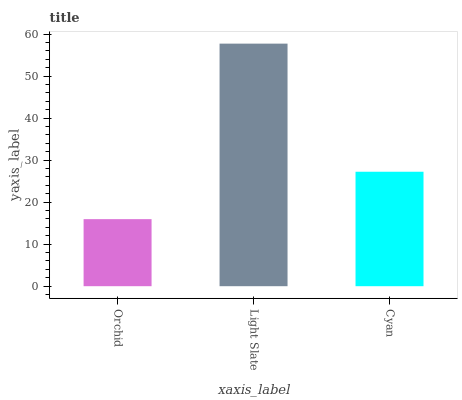Is Orchid the minimum?
Answer yes or no. Yes. Is Light Slate the maximum?
Answer yes or no. Yes. Is Cyan the minimum?
Answer yes or no. No. Is Cyan the maximum?
Answer yes or no. No. Is Light Slate greater than Cyan?
Answer yes or no. Yes. Is Cyan less than Light Slate?
Answer yes or no. Yes. Is Cyan greater than Light Slate?
Answer yes or no. No. Is Light Slate less than Cyan?
Answer yes or no. No. Is Cyan the high median?
Answer yes or no. Yes. Is Cyan the low median?
Answer yes or no. Yes. Is Orchid the high median?
Answer yes or no. No. Is Light Slate the low median?
Answer yes or no. No. 